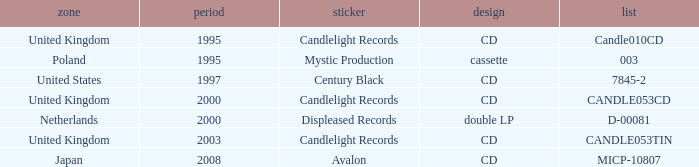What year did Japan form a label? 2008.0. 